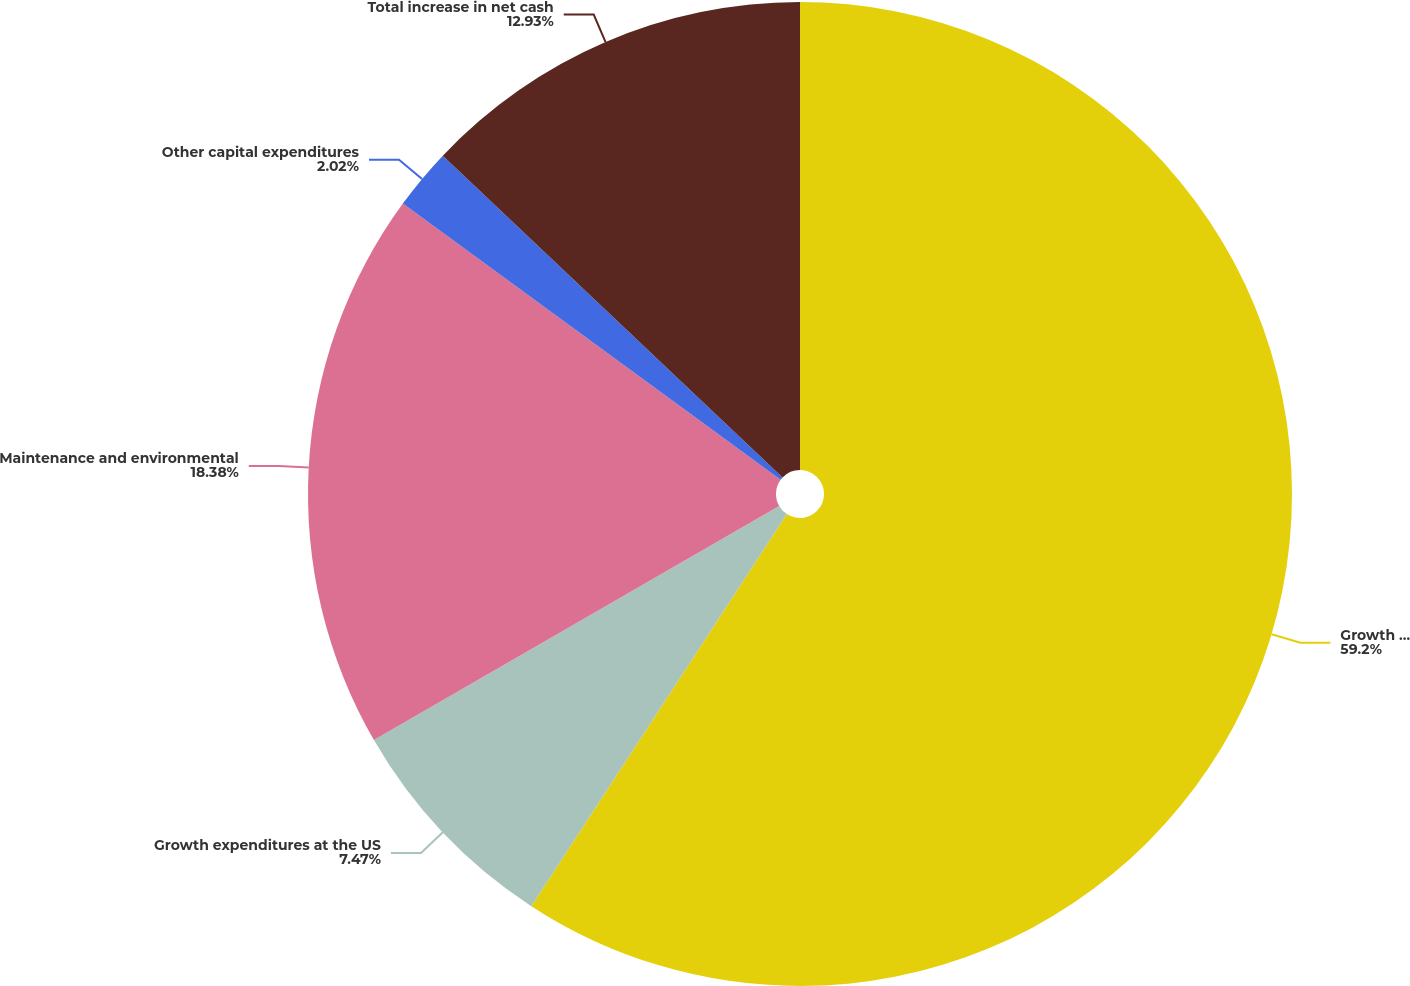Convert chart to OTSL. <chart><loc_0><loc_0><loc_500><loc_500><pie_chart><fcel>Growth expenditures at the<fcel>Growth expenditures at the US<fcel>Maintenance and environmental<fcel>Other capital expenditures<fcel>Total increase in net cash<nl><fcel>59.19%<fcel>7.47%<fcel>18.38%<fcel>2.02%<fcel>12.93%<nl></chart> 